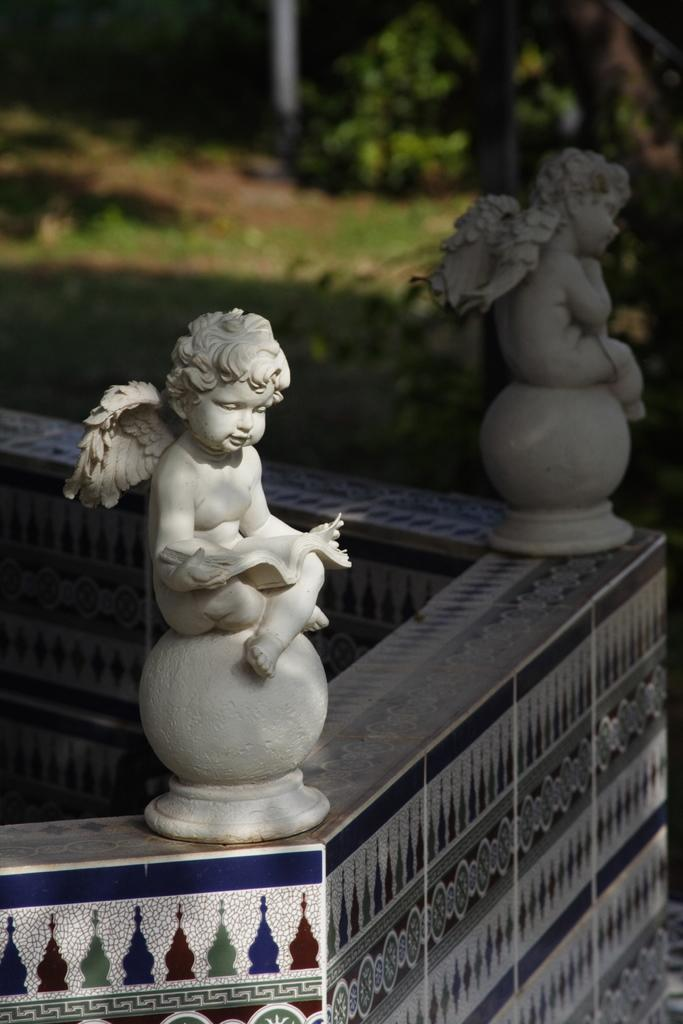How many figures are present in the image? There are two figures in the image. Where are the figures located? The figures are on a path. Can you describe the background of the image? The background of the image is blurred. What type of farm animals can be seen in the image? There are no farm animals present in the image. What specific details about the figures can be observed in the image? The provided facts do not mention any specific details about the figures, so we cannot answer this question definitively. 